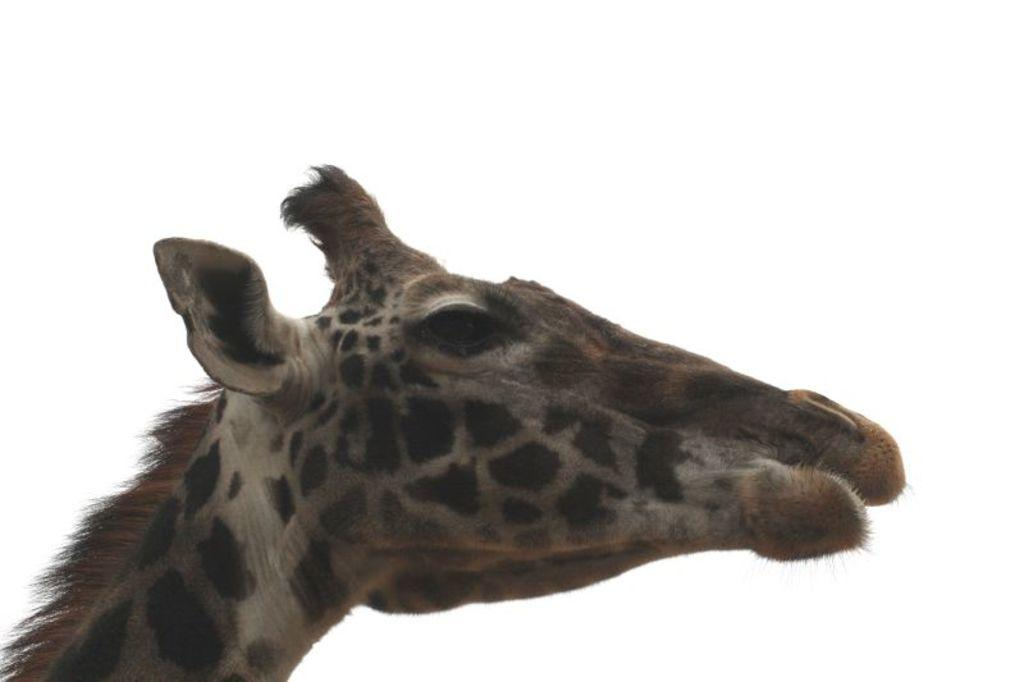What animal's head is featured in the image? There is a head of a giraffe in the image. What type of bed is visible in the image? There is no bed present in the image; it features the head of a giraffe. What attempt is being made by the giraffe in the image? There is no attempt being made by the giraffe in the image, as it is only the head that is visible. 